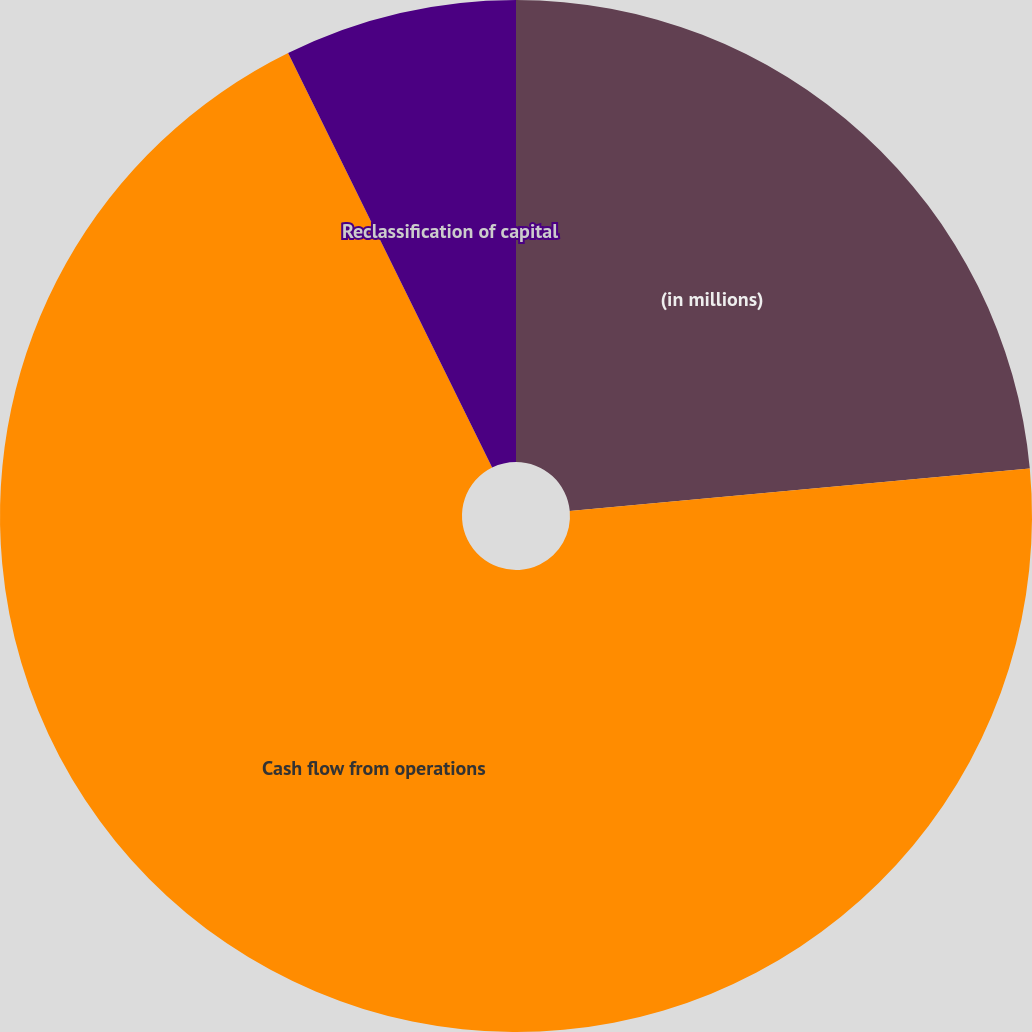Convert chart to OTSL. <chart><loc_0><loc_0><loc_500><loc_500><pie_chart><fcel>(in millions)<fcel>Cash flow from operations<fcel>Reclassification of capital<nl><fcel>23.53%<fcel>69.18%<fcel>7.28%<nl></chart> 